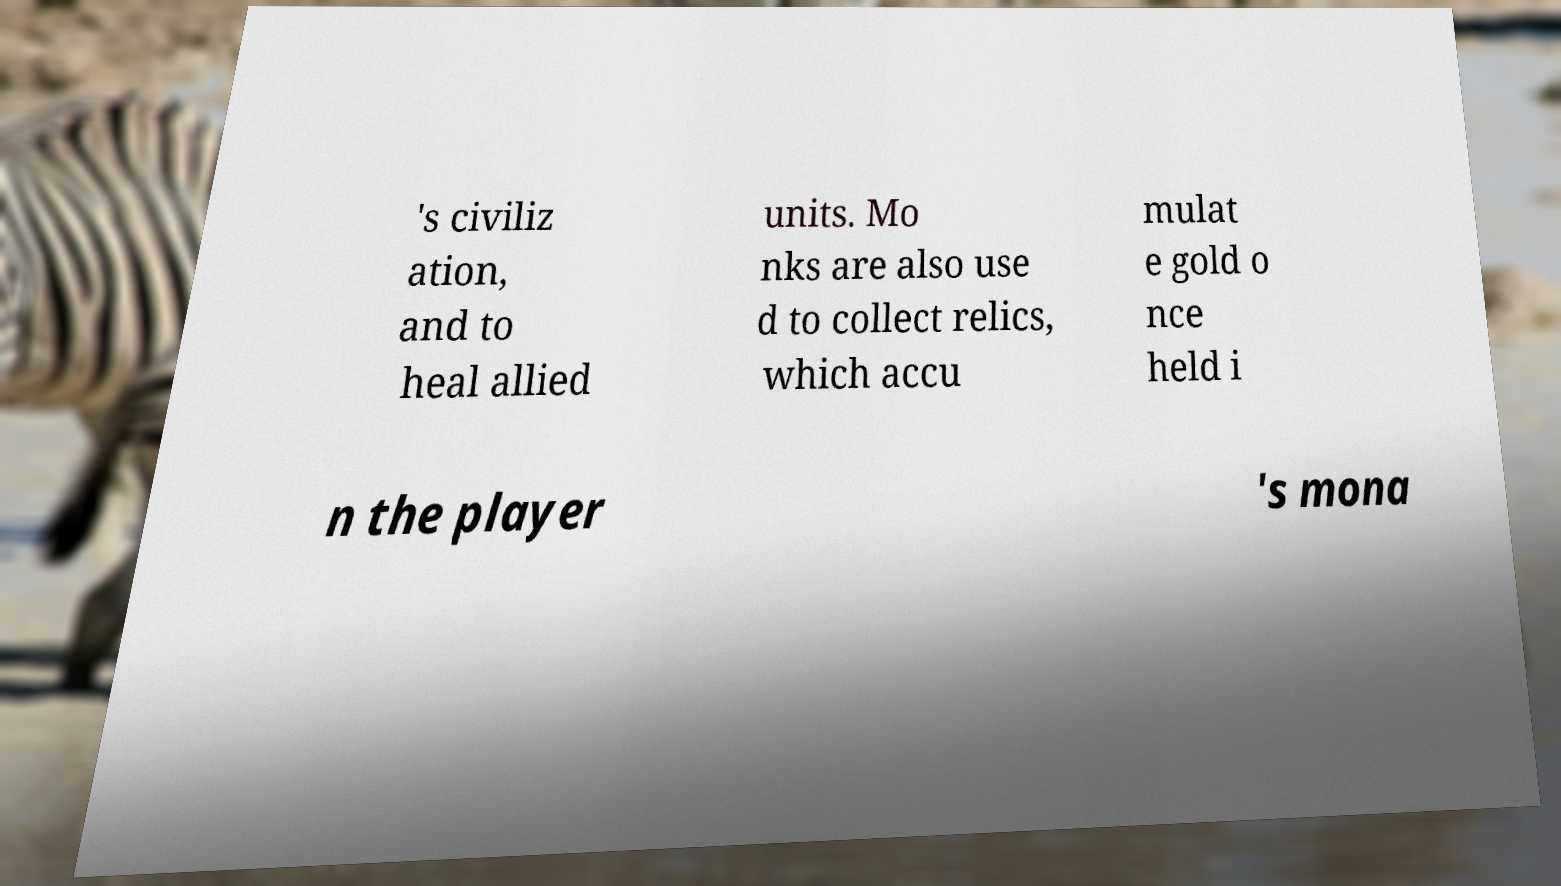What messages or text are displayed in this image? I need them in a readable, typed format. 's civiliz ation, and to heal allied units. Mo nks are also use d to collect relics, which accu mulat e gold o nce held i n the player 's mona 